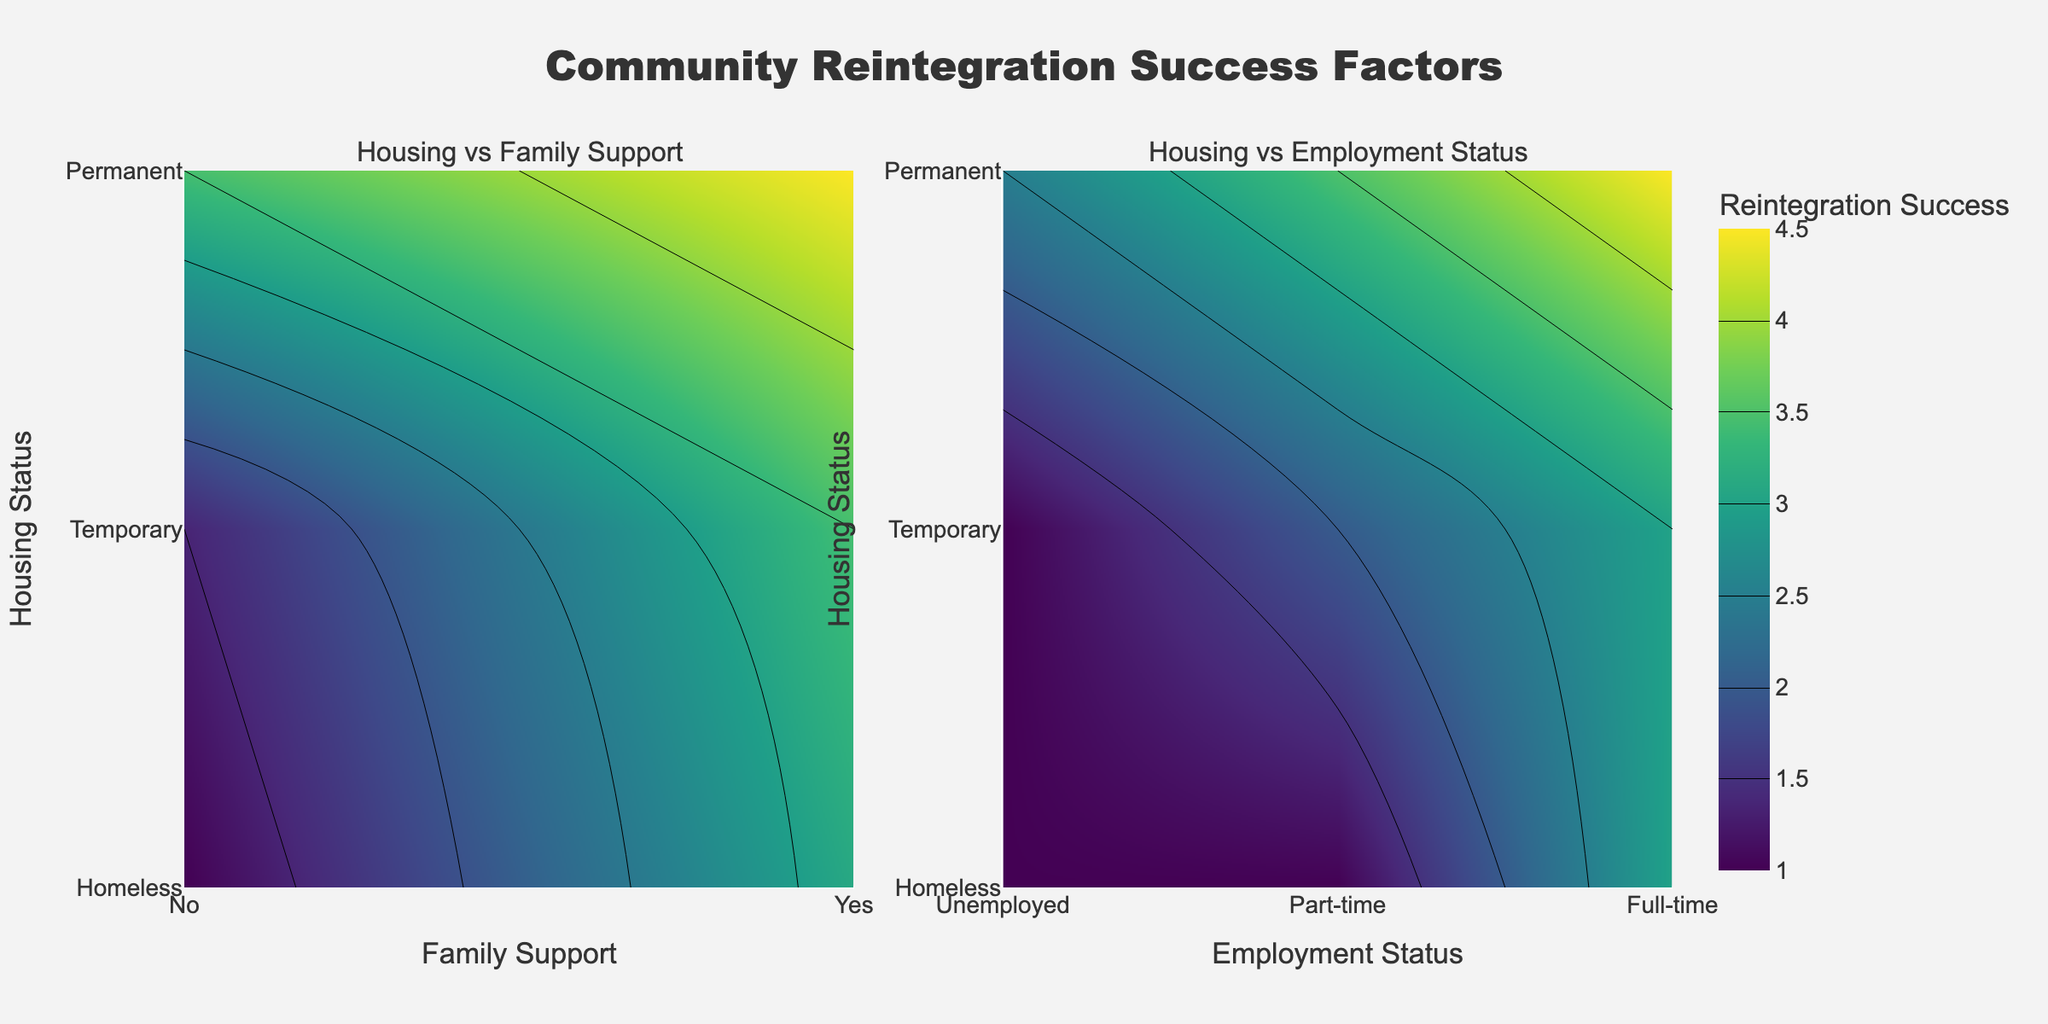What is the title of the figure? The title is usually displayed at the top of the figure in a larger and bold font. For this figure, it is "Community Reintegration Success Factors".
Answer: Community Reintegration Success Factors Which factors are being compared in the first subplot? The first subplot compares "Housing Status" on the y-axis and "Family Support" on the x-axis. The axis titles and tick labels indicate this information.
Answer: Housing Status and Family Support Which housing status has the highest reintegration success when family support is present? In the first subplot, the color corresponding to the highest reintegration success (darkest color on the Viridis scale) when family support is "Yes" (1 on the x-axis) is for "Permanent" housing (2 on the y-axis).
Answer: Permanent Housing Is employment status considered in the first subplot? The first subplot only compares "Housing Status" and "Family Support" and does not include "Employment Status". This is indicated by the labels on the x- and y-axes and the title of the subplot.
Answer: No Which subplot shows the effect of employment status on reintegration success? The second subplot titled "Housing vs Employment Status" shows the comparison of "Housing Status" on the y-axis and "Employment Status" on the x-axis.
Answer: The second subplot Is reintegration success generally higher for those with family support compared to those without? In the first subplot, the colors representing higher success rates (darker gradients) are generally found on the right side (Family Support: Yes) compared to the left side (Family Support: No).
Answer: Yes What is the reintegration success for someone with a temporary housing status and part-time employment? In the second subplot, locate the intersection of "Temporary" (1 on the y-axis) and "Part-time" (1 on the x-axis). This point shows a medium-high success rate indicated by the corresponding color.
Answer: Medium-high Which combination yields the highest reintegration success in the second subplot? The combination of "Permanent" housing (2 on the y-axis) and "Full-time" employment (2 on the x-axis) shows the darkest color, indicating the highest success rate.
Answer: Permanent Housing and Full-time Employment How does the reintegration success for unemployed individuals vary with housing status? In the second subplot, observe the success rate for "Unemployed" (0 on the x-axis). The colors become darker as housing status improves from "Homeless" (0 on the y-axis) to "Permanent" (2 on the y-axis), indicating an increase in success.
Answer: Increases with better housing Does having family support noticeably improve reintegration success for homeless individuals? In the first subplot, compare the colors for "Homeless" (0 on the y-axis) across "No" and "Yes" family support (0 and 1 on the x-axis). The colors shift from lower to higher success rates as family support changes from "No" to "Yes".
Answer: Yes 